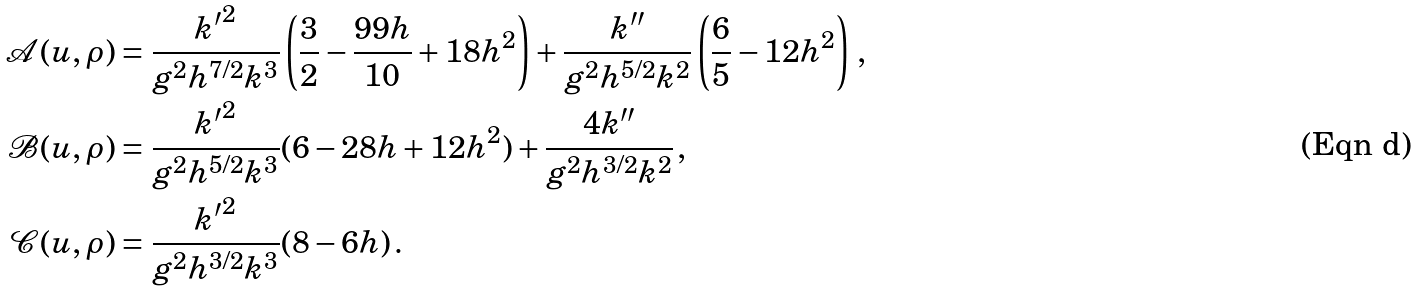Convert formula to latex. <formula><loc_0><loc_0><loc_500><loc_500>\mathcal { A } ( u , \rho ) & = \frac { { k ^ { \prime } } ^ { 2 } } { g ^ { 2 } h ^ { 7 / 2 } k ^ { 3 } } \left ( \frac { 3 } { 2 } - \frac { 9 9 h } { 1 0 } + 1 8 h ^ { 2 } \right ) + \frac { k ^ { \prime \prime } } { g ^ { 2 } h ^ { 5 / 2 } k ^ { 2 } } \left ( \frac { 6 } { 5 } - 1 2 h ^ { 2 } \right ) \, , \\ \mathcal { B } ( u , \rho ) & = \frac { { k ^ { \prime } } ^ { 2 } } { g ^ { 2 } h ^ { 5 / 2 } k ^ { 3 } } ( 6 - 2 8 h + 1 2 h ^ { 2 } ) + \frac { 4 k ^ { \prime \prime } } { g ^ { 2 } h ^ { 3 / 2 } k ^ { 2 } } \, , \\ \mathcal { C } ( u , \rho ) & = \frac { { k ^ { \prime } } ^ { 2 } } { g ^ { 2 } h ^ { 3 / 2 } k ^ { 3 } } ( 8 - 6 h ) \, .</formula> 